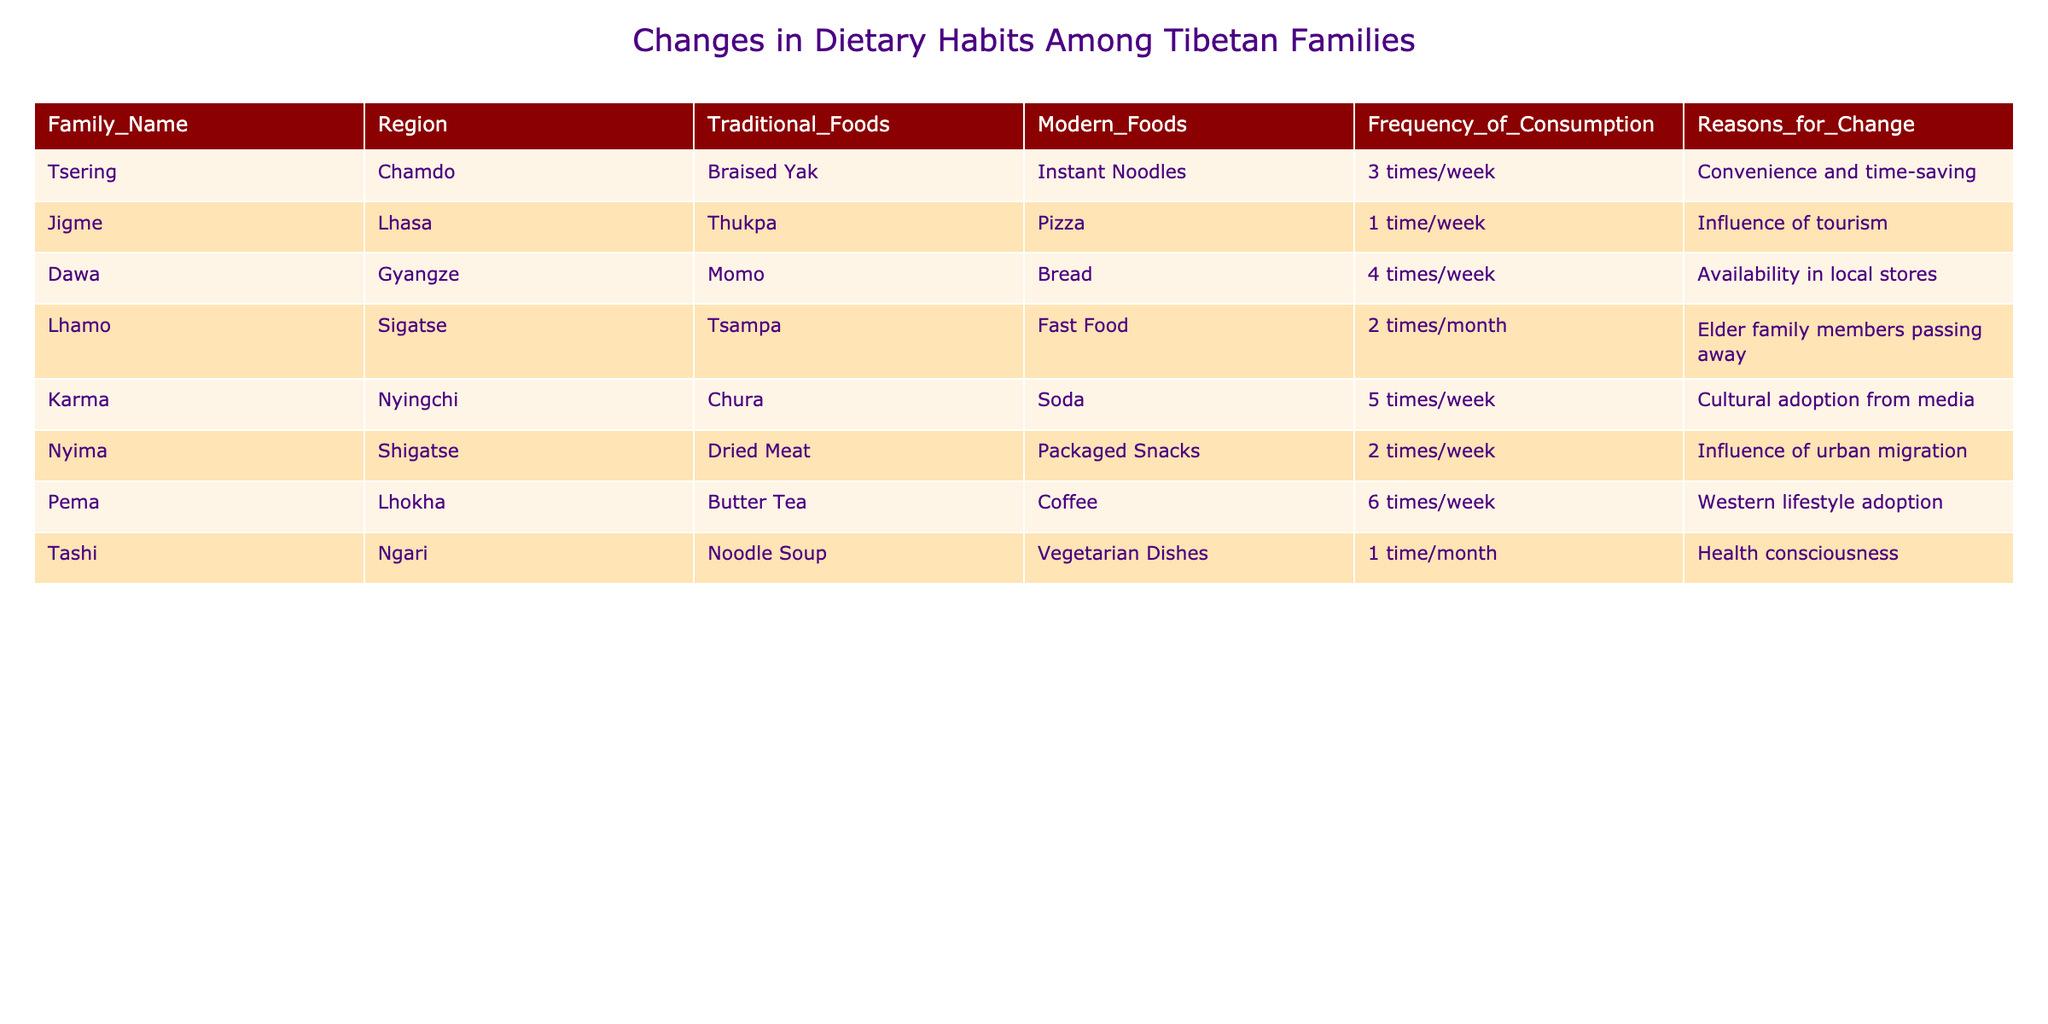What is the most frequently consumed modern food among Tibetan families? To find the most frequently consumed modern food, we can look at the "Modern_Foods" column and find the food item with the highest "Frequency_of_Consumption." In this case, the highest frequency is for "Soda," consumed 5 times a week by Karma.
Answer: Soda How many times a week do families in Gyangze consume traditional foods? Referring to the "Frequency_of_Consumption" for Gyangze, which is 4 times a week, we can identify how often traditional foods are consumed in that region.
Answer: 4 times/week Is there any family consuming traditional foods once a month? Looking at the "Frequency_of_Consumption" column, only Tashi, from Ngari, is recorded as consuming traditional foods 1 time/month. Therefore, the answer is yes.
Answer: Yes What is the average frequency of modern food consumption among the families in the table? First, we convert the frequency values to a numerical format: 3 (Tsering) + 1 (Jigme) + 4 (Dawa) + 2 (Lhamo) + 5 (Karma) + 2 (Nyima) + 6 (Pema) + 1 (Tashi) = 24. There are 8 families, so we divide 24 by 8, giving us an average of 3.
Answer: 3 Which family cited "Influence of tourism" as a reason for changing their dietary habits? In the "Reasons_for_Change" column, we can locate the family that mentioned "Influence of tourism." That family is Jigme from Lhasa.
Answer: Jigme How many families consume either "Fast Food" or "Instant Noodles"? Looking at the "Modern_Foods" column, we check for instances of "Fast Food" and "Instant Noodles." "Fast Food" is consumed by Lhamo and "Instant Noodles" by Tsering, giving a total of 2 families.
Answer: 2 families Do any families consume traditional foods more than 5 times a week? On checking the "Frequency_of_Consumption" column, we find that Pema consumes Butter Tea 6 times a week, which is more than 5 times. Therefore, the answer is yes.
Answer: Yes What is the total frequency of consumption for traditional foods among families in the Lhokha region? The family from Lhokha is Pema, who consumes Butter Tea 6 times a week. Thus, the total frequency for traditional foods in that region is just 6.
Answer: 6 How many families’ dietary changes are influenced by cultural adoption from the media? From the "Reasons_for_Change," we see that only Karma has stated that their dietary changes are influenced by media. Therefore, the answer is 1 family.
Answer: 1 family 